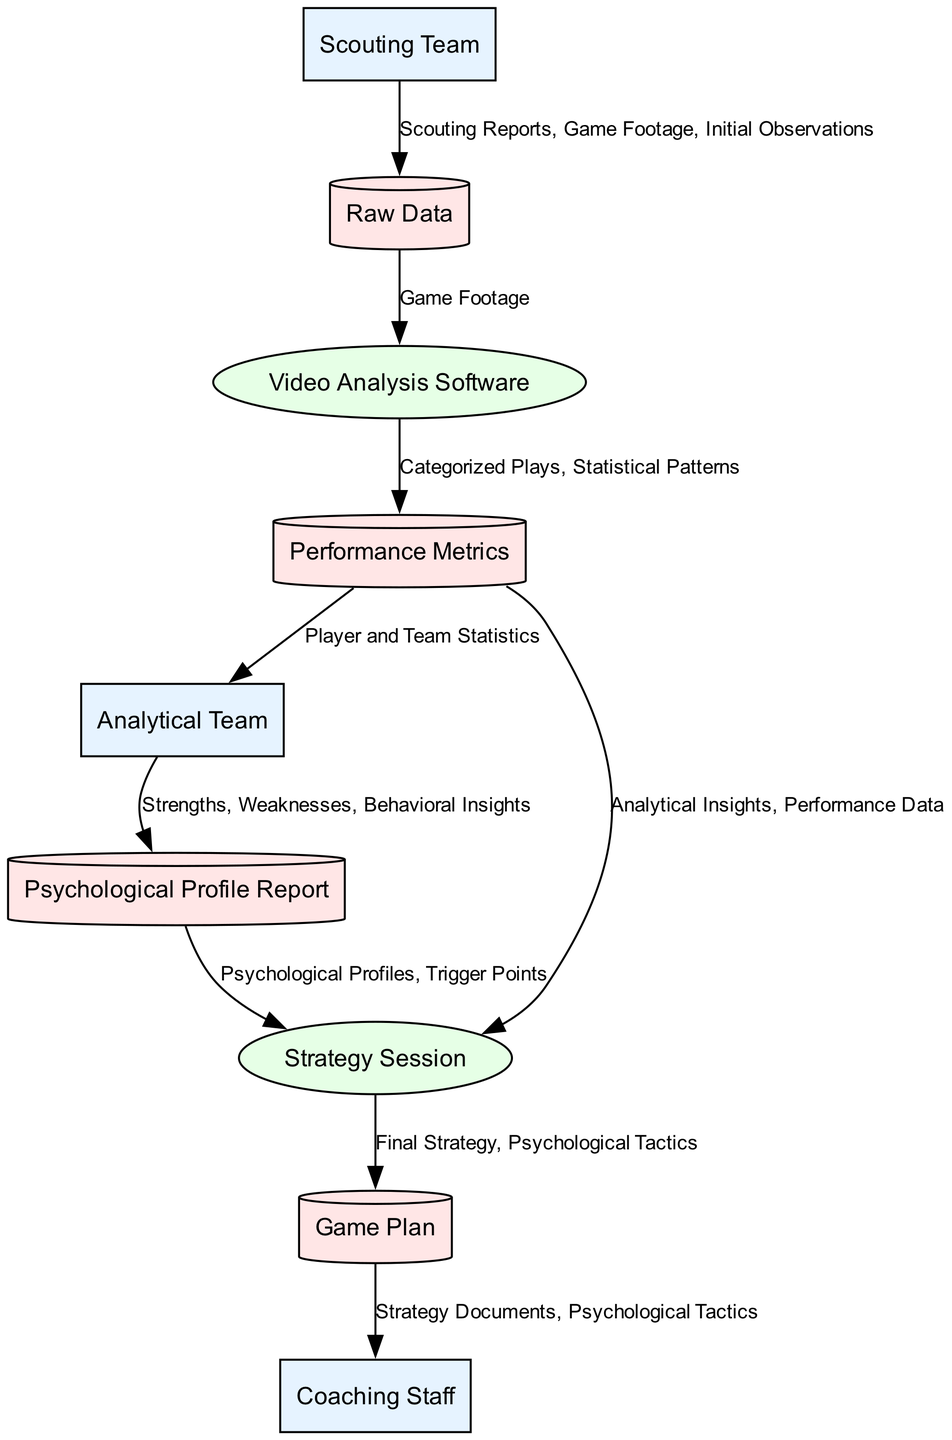What is the starting point for collecting data about opponents? The starting point is the "Scouting Team," which is responsible for gathering the initial data. This team initiates the workflow by sending scouting reports and observations.
Answer: Scouting Team How many data stores are represented in the diagram? The diagram includes four data stores: "Raw Data," "Performance Metrics," "Psychological Profile Report," and "Game Plan." Counting these gives us the total of four.
Answer: Four What type of entity is the "Analytical Team"? The "Analytical Team" is classified as an "External Entity," indicating that it operates outside the internal processes of the team but interacts with the data.
Answer: External Entity Which process receives data from the "Performance Metrics"? The "Strategy Session" receives data from "Performance Metrics," specifically analytical insights and performance data for strategy development.
Answer: Strategy Session What types of insights are included in the "Psychological Profile Report"? The report contains "Strengths," "Weaknesses," and "Behavioral Insights" about the opponents, allowing teams to strategize effectively.
Answer: Strengths, Weaknesses, Behavioral Insights Who implements the "Game Plan"? The "Coaching Staff" is responsible for implementing the game plan during games and making real-time adjustments as necessary based on the strategy documents provided.
Answer: Coaching Staff What data does the "Scouting Team" provide to the "Raw Data" store? The "Scouting Team" provides "Scouting Reports," "Game Footage," and "Initial Observations" to the "Raw Data" data store for later analysis.
Answer: Scouting Reports, Game Footage, Initial Observations In what order does data flow from the "Video Analysis Software" to the next process? After being processed, data flows from the "Video Analysis Software" to the "Performance Metrics," which stores categorized plays and statistical patterns.
Answer: Performance Metrics Which external entity analyzes the metrics for identifying weaknesses? The "Analytical Team" is the entity that analyzes performance metrics to uncover strengths and weaknesses, providing crucial insights for the team.
Answer: Analytical Team 